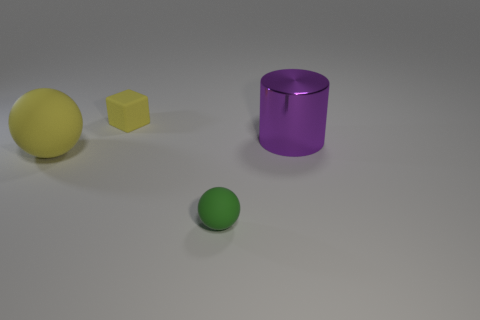Add 4 tiny rubber blocks. How many objects exist? 8 Subtract all green balls. Subtract all green cubes. How many balls are left? 1 Subtract all yellow blocks. How many cyan cylinders are left? 0 Subtract all small cubes. Subtract all tiny yellow metallic cylinders. How many objects are left? 3 Add 2 big shiny cylinders. How many big shiny cylinders are left? 3 Add 4 large yellow rubber objects. How many large yellow rubber objects exist? 5 Subtract 0 cyan balls. How many objects are left? 4 Subtract all cylinders. How many objects are left? 3 